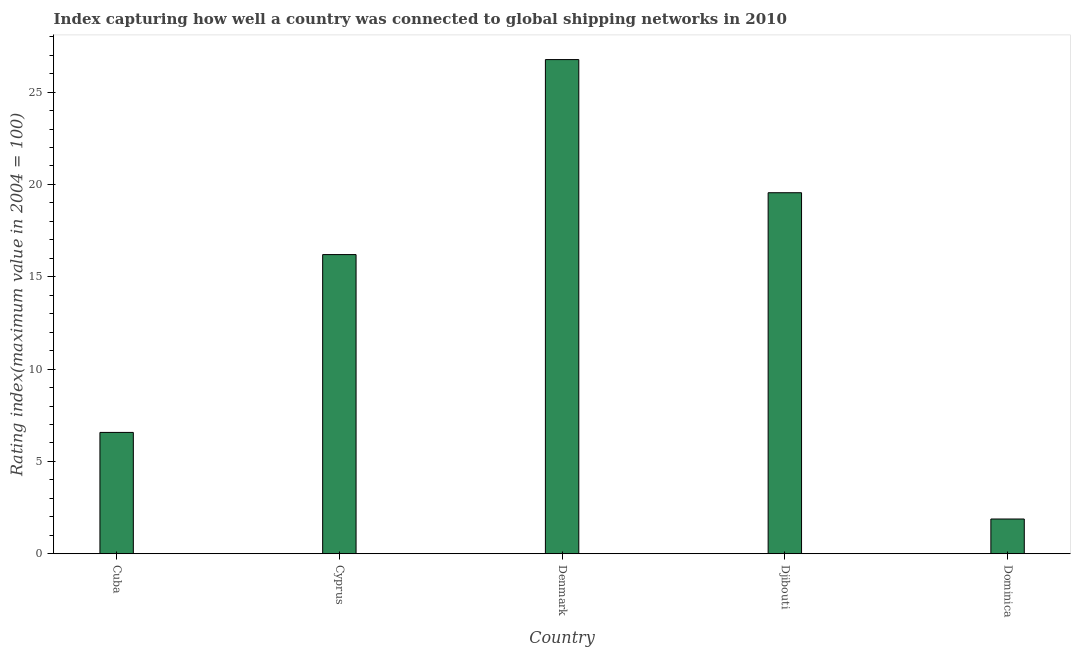Does the graph contain any zero values?
Your answer should be compact. No. Does the graph contain grids?
Make the answer very short. No. What is the title of the graph?
Keep it short and to the point. Index capturing how well a country was connected to global shipping networks in 2010. What is the label or title of the X-axis?
Provide a succinct answer. Country. What is the label or title of the Y-axis?
Keep it short and to the point. Rating index(maximum value in 2004 = 100). What is the liner shipping connectivity index in Dominica?
Ensure brevity in your answer.  1.88. Across all countries, what is the maximum liner shipping connectivity index?
Your response must be concise. 26.76. Across all countries, what is the minimum liner shipping connectivity index?
Make the answer very short. 1.88. In which country was the liner shipping connectivity index minimum?
Your response must be concise. Dominica. What is the sum of the liner shipping connectivity index?
Make the answer very short. 70.96. What is the difference between the liner shipping connectivity index in Cuba and Dominica?
Offer a very short reply. 4.69. What is the average liner shipping connectivity index per country?
Keep it short and to the point. 14.19. What is the median liner shipping connectivity index?
Give a very brief answer. 16.2. In how many countries, is the liner shipping connectivity index greater than 12 ?
Keep it short and to the point. 3. What is the ratio of the liner shipping connectivity index in Cyprus to that in Dominica?
Provide a succinct answer. 8.62. Is the liner shipping connectivity index in Denmark less than that in Djibouti?
Make the answer very short. No. What is the difference between the highest and the second highest liner shipping connectivity index?
Your answer should be compact. 7.21. What is the difference between the highest and the lowest liner shipping connectivity index?
Your response must be concise. 24.88. In how many countries, is the liner shipping connectivity index greater than the average liner shipping connectivity index taken over all countries?
Provide a succinct answer. 3. How many countries are there in the graph?
Your answer should be compact. 5. What is the Rating index(maximum value in 2004 = 100) of Cuba?
Give a very brief answer. 6.57. What is the Rating index(maximum value in 2004 = 100) in Cyprus?
Your response must be concise. 16.2. What is the Rating index(maximum value in 2004 = 100) in Denmark?
Your answer should be compact. 26.76. What is the Rating index(maximum value in 2004 = 100) in Djibouti?
Give a very brief answer. 19.55. What is the Rating index(maximum value in 2004 = 100) in Dominica?
Make the answer very short. 1.88. What is the difference between the Rating index(maximum value in 2004 = 100) in Cuba and Cyprus?
Ensure brevity in your answer.  -9.63. What is the difference between the Rating index(maximum value in 2004 = 100) in Cuba and Denmark?
Offer a very short reply. -20.19. What is the difference between the Rating index(maximum value in 2004 = 100) in Cuba and Djibouti?
Your answer should be compact. -12.98. What is the difference between the Rating index(maximum value in 2004 = 100) in Cuba and Dominica?
Your answer should be very brief. 4.69. What is the difference between the Rating index(maximum value in 2004 = 100) in Cyprus and Denmark?
Offer a very short reply. -10.56. What is the difference between the Rating index(maximum value in 2004 = 100) in Cyprus and Djibouti?
Your response must be concise. -3.35. What is the difference between the Rating index(maximum value in 2004 = 100) in Cyprus and Dominica?
Your response must be concise. 14.32. What is the difference between the Rating index(maximum value in 2004 = 100) in Denmark and Djibouti?
Offer a very short reply. 7.21. What is the difference between the Rating index(maximum value in 2004 = 100) in Denmark and Dominica?
Give a very brief answer. 24.88. What is the difference between the Rating index(maximum value in 2004 = 100) in Djibouti and Dominica?
Your answer should be very brief. 17.67. What is the ratio of the Rating index(maximum value in 2004 = 100) in Cuba to that in Cyprus?
Keep it short and to the point. 0.41. What is the ratio of the Rating index(maximum value in 2004 = 100) in Cuba to that in Denmark?
Offer a terse response. 0.25. What is the ratio of the Rating index(maximum value in 2004 = 100) in Cuba to that in Djibouti?
Give a very brief answer. 0.34. What is the ratio of the Rating index(maximum value in 2004 = 100) in Cuba to that in Dominica?
Ensure brevity in your answer.  3.5. What is the ratio of the Rating index(maximum value in 2004 = 100) in Cyprus to that in Denmark?
Give a very brief answer. 0.6. What is the ratio of the Rating index(maximum value in 2004 = 100) in Cyprus to that in Djibouti?
Keep it short and to the point. 0.83. What is the ratio of the Rating index(maximum value in 2004 = 100) in Cyprus to that in Dominica?
Offer a very short reply. 8.62. What is the ratio of the Rating index(maximum value in 2004 = 100) in Denmark to that in Djibouti?
Offer a very short reply. 1.37. What is the ratio of the Rating index(maximum value in 2004 = 100) in Denmark to that in Dominica?
Provide a short and direct response. 14.23. What is the ratio of the Rating index(maximum value in 2004 = 100) in Djibouti to that in Dominica?
Keep it short and to the point. 10.4. 